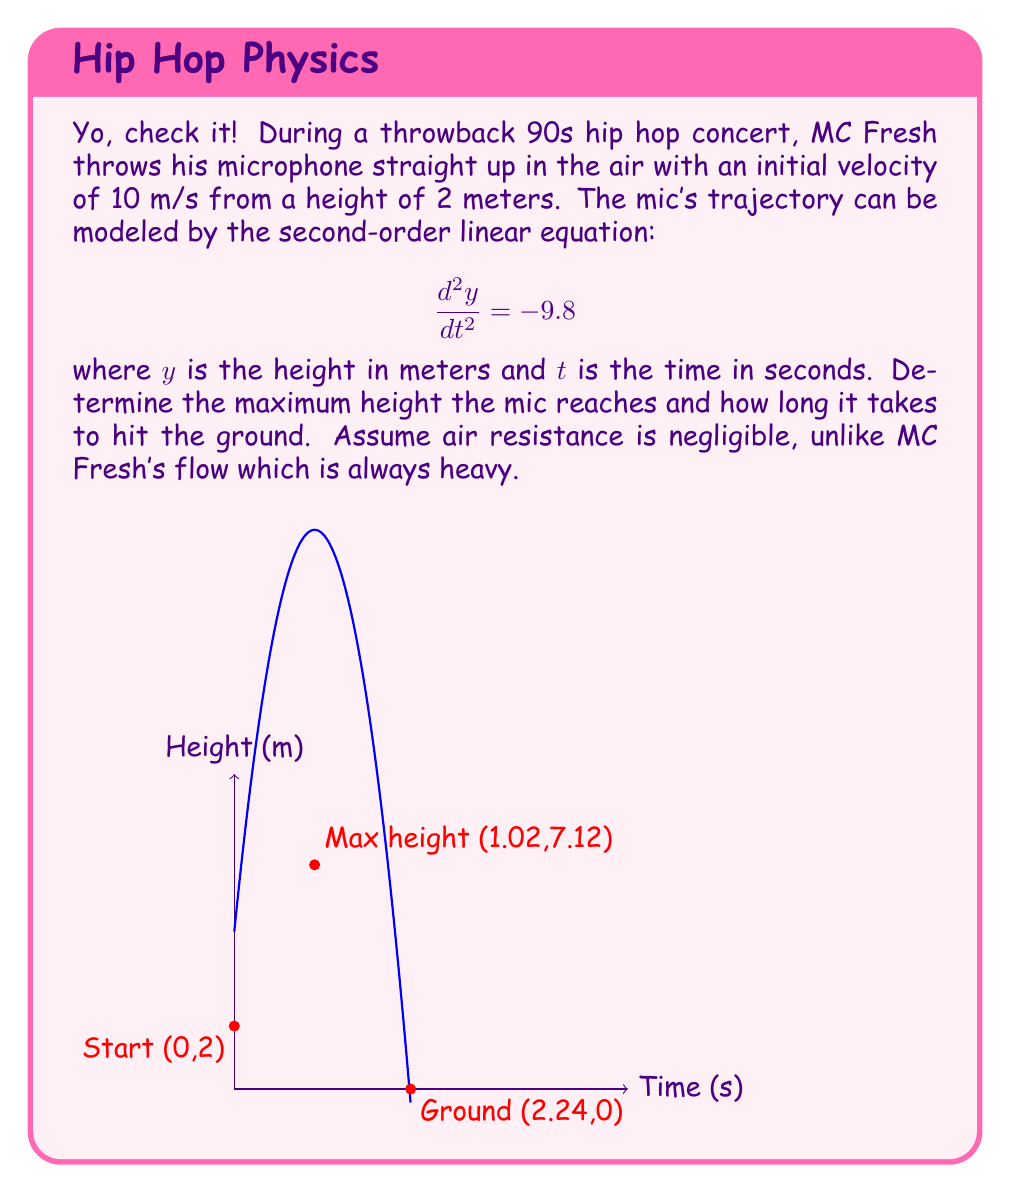Could you help me with this problem? Let's break this down step by step, homie:

1) The general solution for this second-order linear equation is:
   $$y(t) = -4.9t^2 + v_0t + y_0$$
   where $v_0$ is the initial velocity and $y_0$ is the initial height.

2) Plugging in our initial conditions:
   $$y(t) = -4.9t^2 + 10t + 2$$

3) To find the maximum height, we need to find when the velocity is zero:
   $$\frac{dy}{dt} = -9.8t + 10 = 0$$
   $$t = \frac{10}{9.8} \approx 1.02\text{ seconds}$$

4) Plugging this time back into our original equation:
   $$y(1.02) = -4.9(1.02)^2 + 10(1.02) + 2 \approx 7.12\text{ meters}$$

5) To find when the mic hits the ground, set $y(t) = 0$:
   $$0 = -4.9t^2 + 10t + 2$$
   $$4.9t^2 - 10t - 2 = 0$$

6) Using the quadratic formula:
   $$t = \frac{10 \pm \sqrt{100 + 4(4.9)(2)}}{2(4.9)} \approx 2.24\text{ seconds}$$
   (We take the positive root as time can't be negative)

Therefore, the mic reaches a maximum height of about 7.12 meters after 1.02 seconds and hits the ground after about 2.24 seconds.
Answer: Maximum height: 7.12 m; Time to hit ground: 2.24 s 